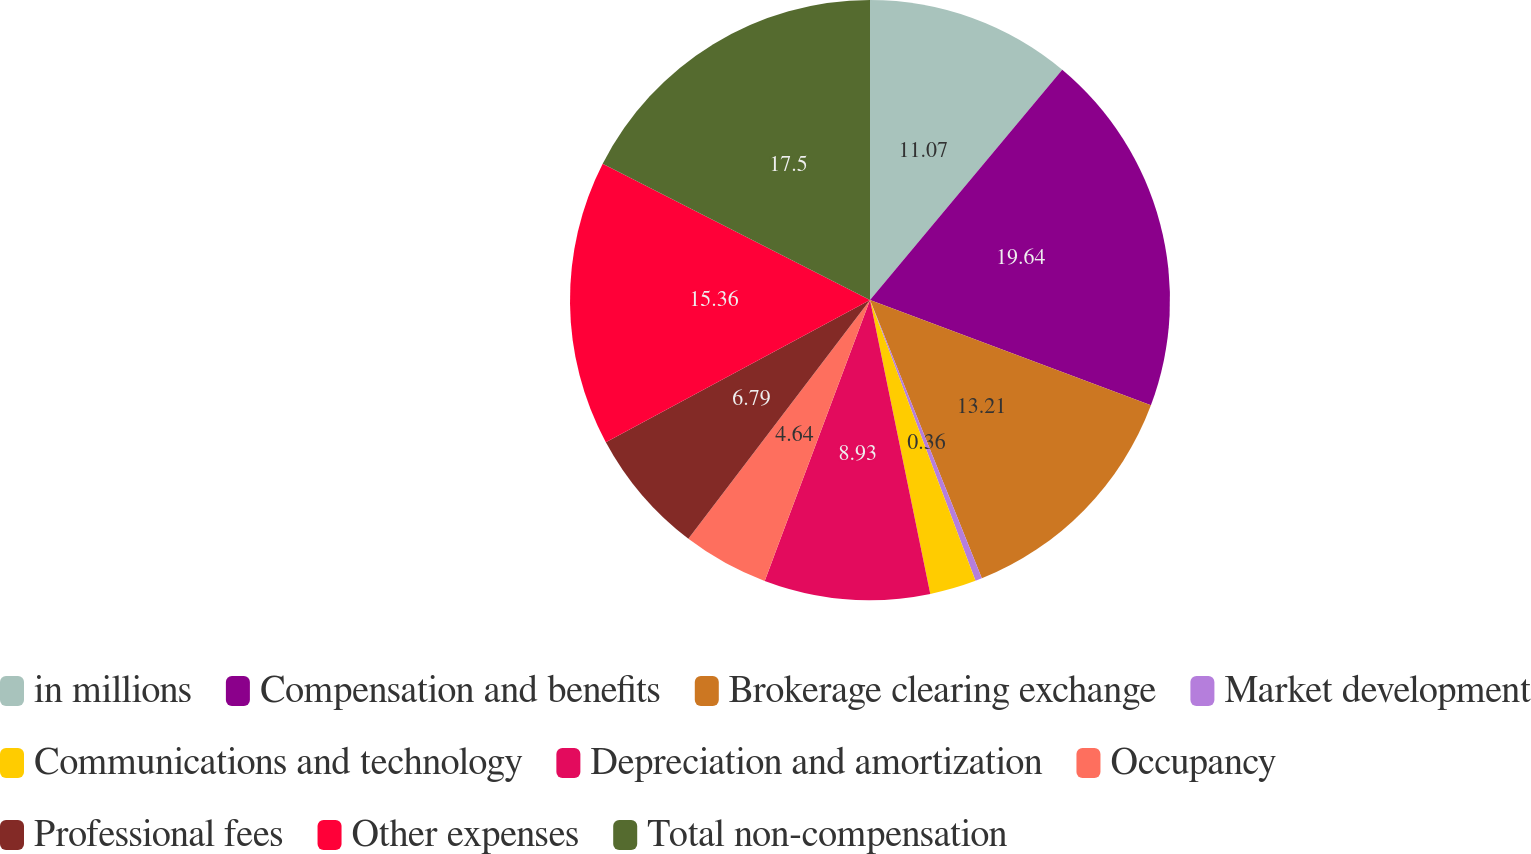<chart> <loc_0><loc_0><loc_500><loc_500><pie_chart><fcel>in millions<fcel>Compensation and benefits<fcel>Brokerage clearing exchange<fcel>Market development<fcel>Communications and technology<fcel>Depreciation and amortization<fcel>Occupancy<fcel>Professional fees<fcel>Other expenses<fcel>Total non-compensation<nl><fcel>11.07%<fcel>19.64%<fcel>13.21%<fcel>0.36%<fcel>2.5%<fcel>8.93%<fcel>4.64%<fcel>6.79%<fcel>15.36%<fcel>17.5%<nl></chart> 